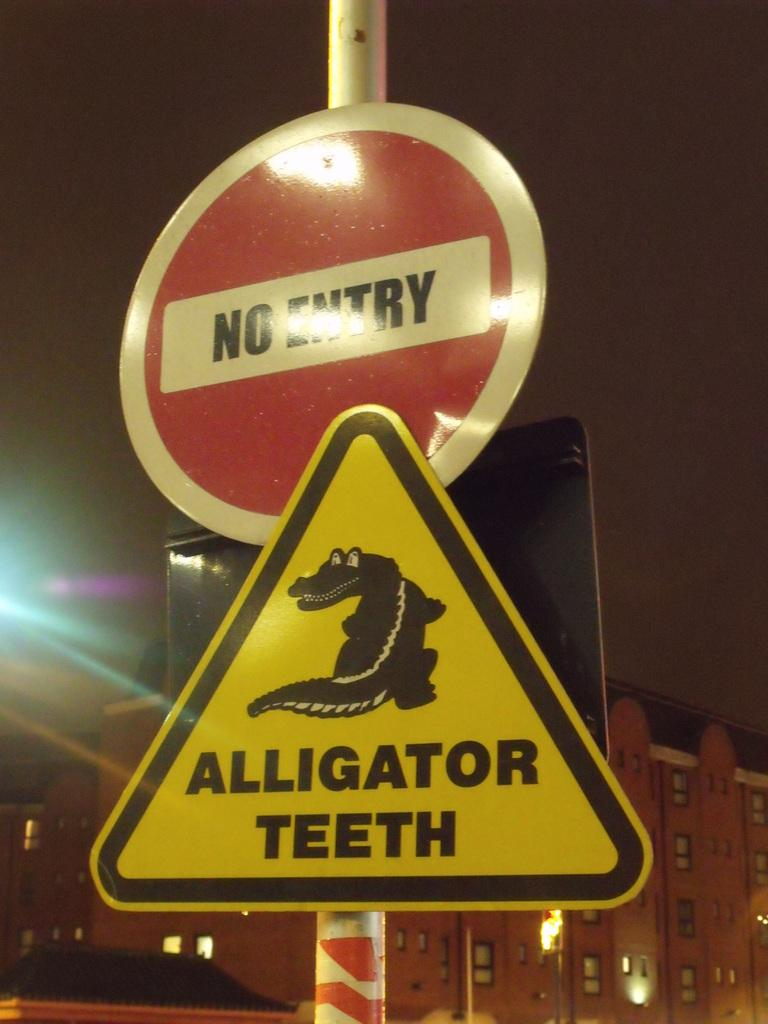<image>
Relay a brief, clear account of the picture shown. A yellow yield sign with an alligator picture on it is below a red and white sign that says No Entry. 